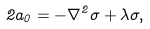<formula> <loc_0><loc_0><loc_500><loc_500>2 a _ { 0 } = - \nabla ^ { 2 } \sigma + \lambda \sigma ,</formula> 